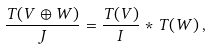<formula> <loc_0><loc_0><loc_500><loc_500>\frac { T ( V \oplus W ) } { J } = \frac { T ( V ) } { I } \ast T ( W ) \, ,</formula> 